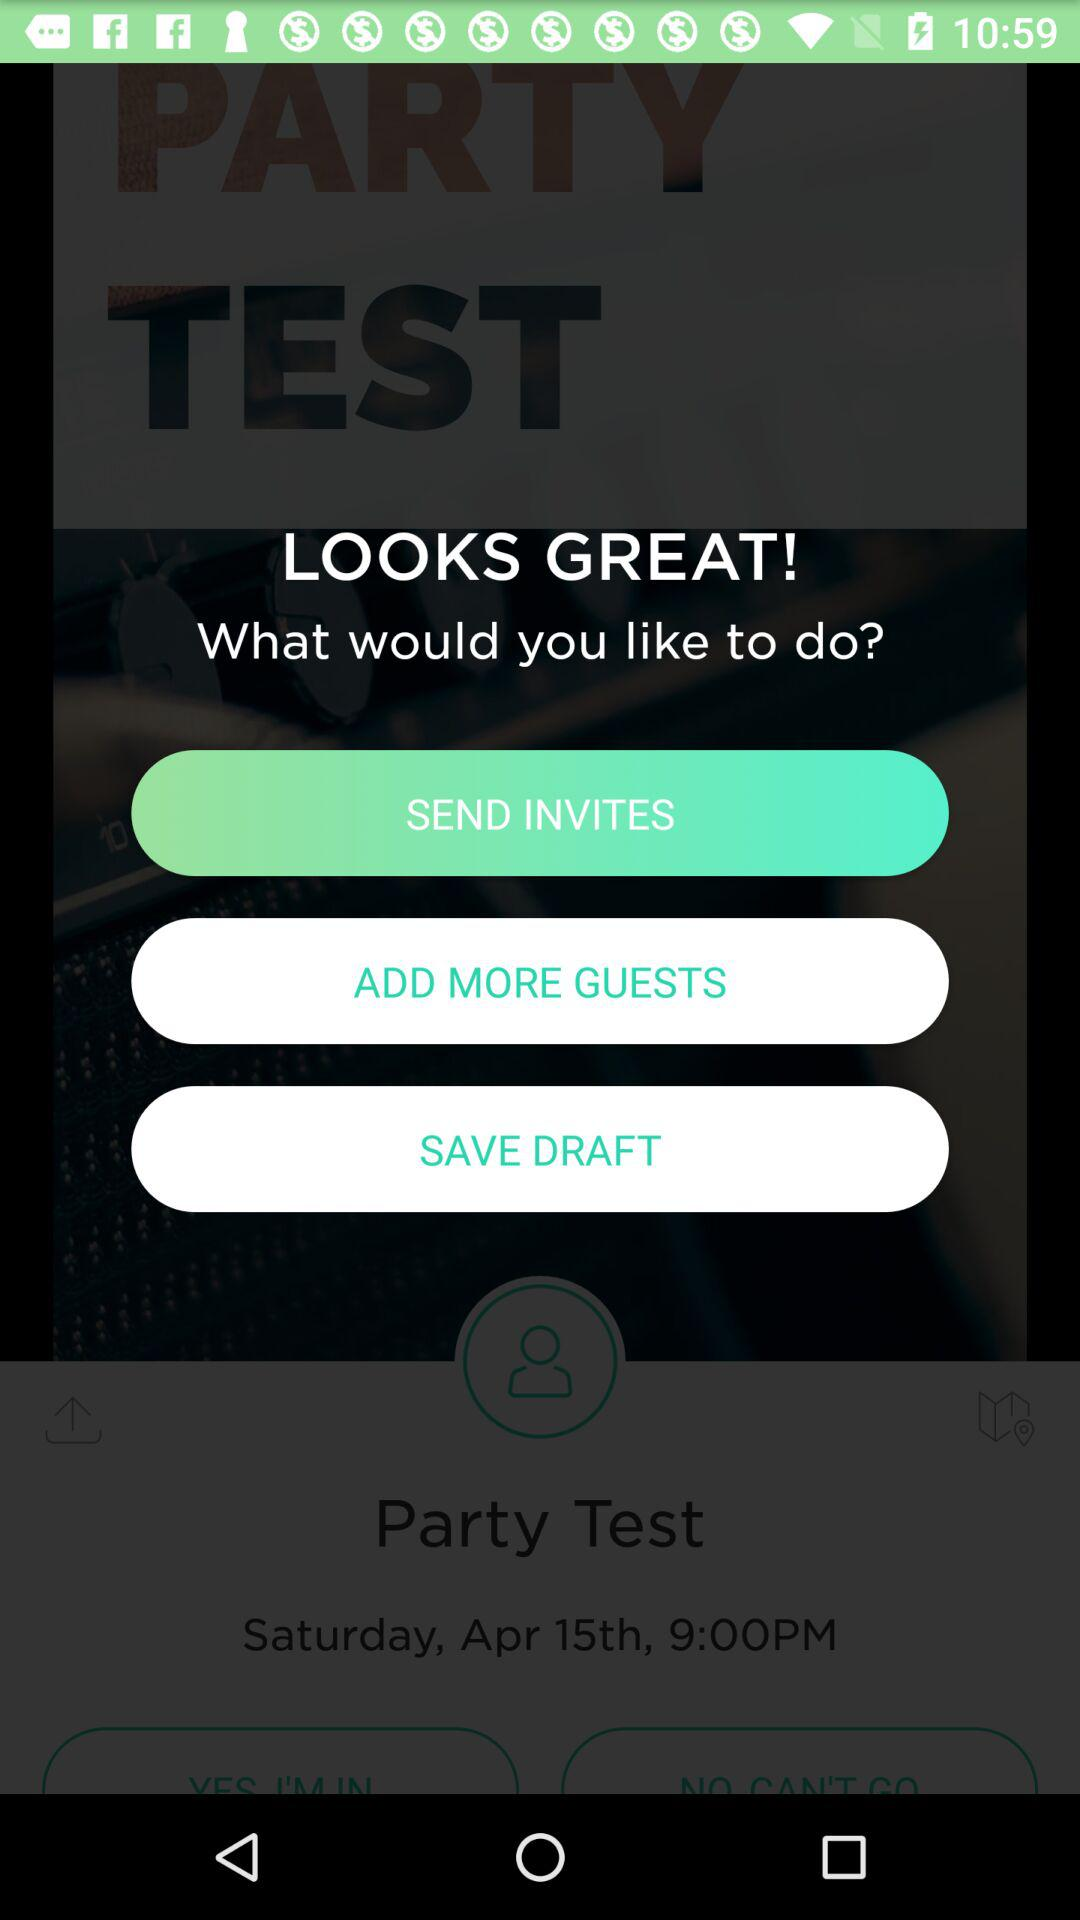What date has been set for the party test? The set date is Saturday, April 15th. 